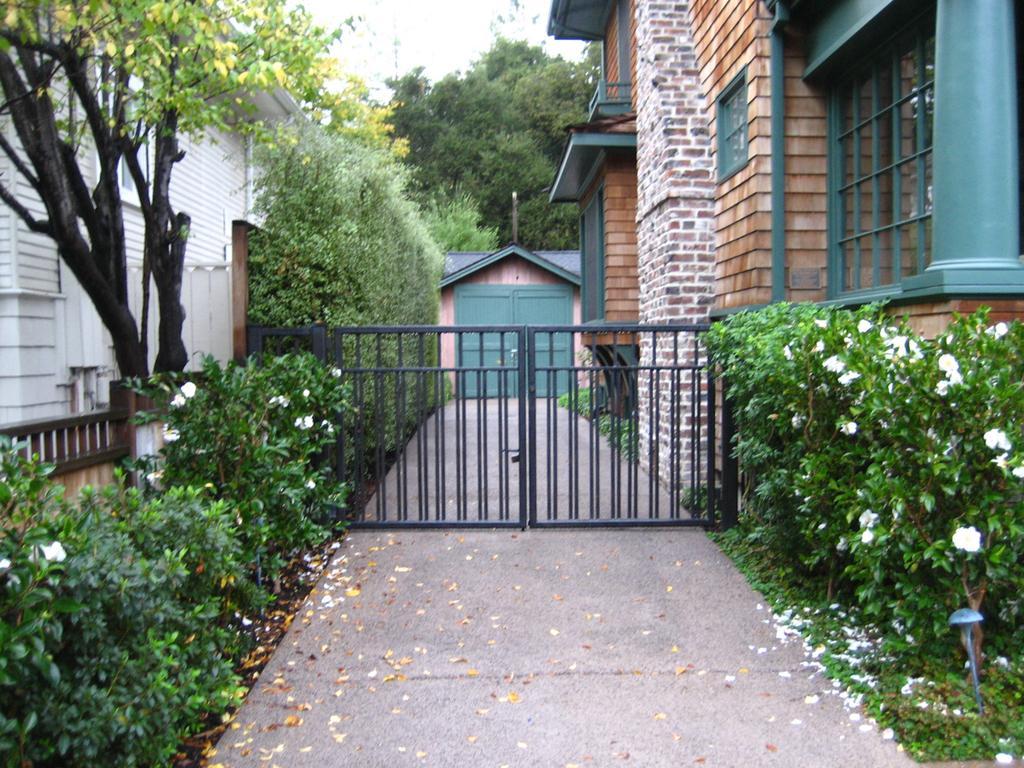How would you summarize this image in a sentence or two? As we can see in the image there are plants, flowers, buildings, trees, gate and sky. 